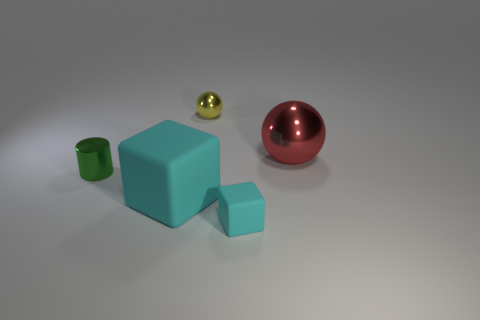Is the number of red metal things that are on the right side of the big red metal object less than the number of large yellow matte blocks?
Your answer should be compact. No. How many tiny rubber cubes have the same color as the big matte object?
Make the answer very short. 1. What is the size of the cyan rubber object that is on the left side of the small metal ball?
Your response must be concise. Large. The rubber object that is on the left side of the rubber thing that is to the right of the rubber object that is on the left side of the tiny cyan cube is what shape?
Your answer should be compact. Cube. What shape is the small object that is in front of the yellow object and behind the big cyan matte block?
Offer a very short reply. Cylinder. Is there a red rubber block that has the same size as the red metal object?
Your answer should be very brief. No. Is the shape of the tiny metal object behind the green thing the same as  the red object?
Make the answer very short. Yes. Is the shape of the large red shiny thing the same as the yellow thing?
Keep it short and to the point. Yes. Is there a big red metallic object of the same shape as the tiny yellow shiny object?
Give a very brief answer. Yes. What shape is the cyan thing right of the metal ball behind the large red thing?
Your answer should be very brief. Cube. 